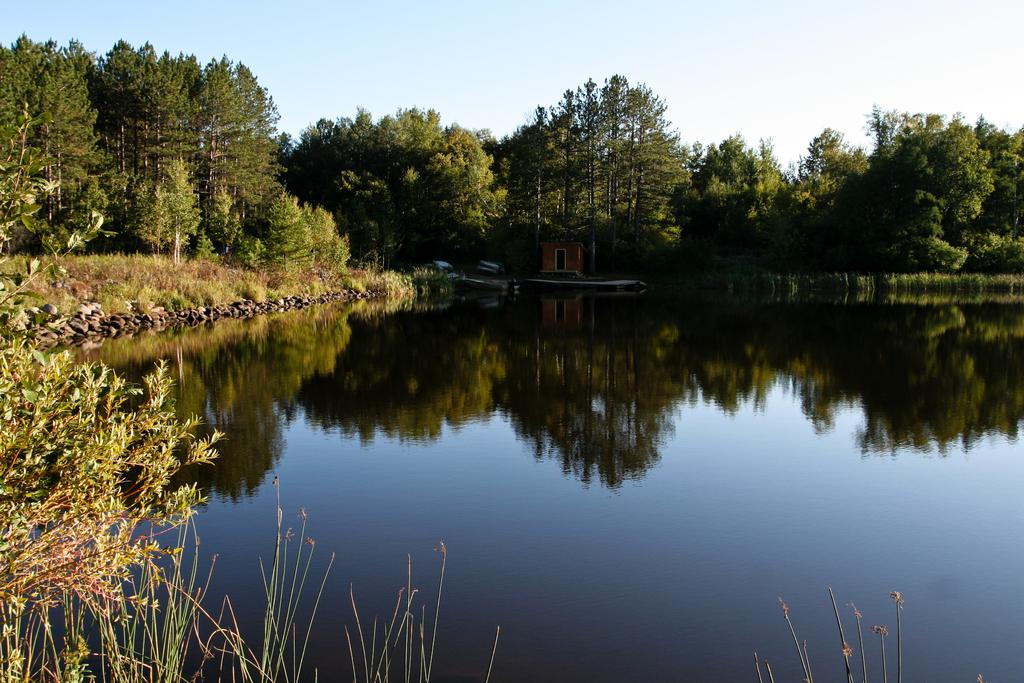What is the primary element visible in the image? There is water in the image. What can be found on the left side of the image? There are stones, plants, and trees on the left side of the image. What is located in the background of the image? There is a small building, trees, and the sky visible in the background of the image. What type of fang can be seen in the image? There is no fang present in the image. What company is responsible for the small building in the background? The image does not provide information about the company responsible for the small building in the background. 